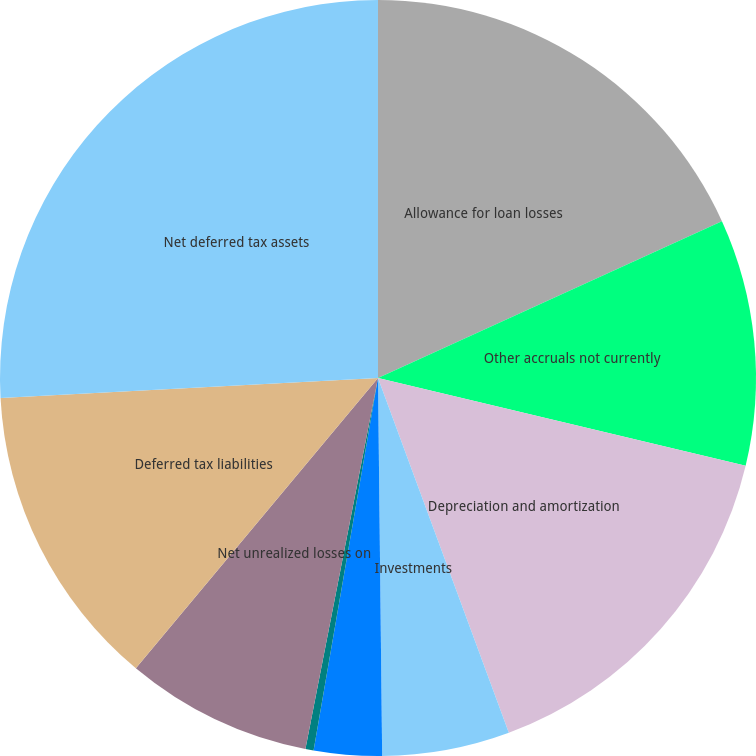Convert chart. <chart><loc_0><loc_0><loc_500><loc_500><pie_chart><fcel>Allowance for loan losses<fcel>Other accruals not currently<fcel>Depreciation and amortization<fcel>Investments<fcel>Losses from pass-through<fcel>Other deferred tax liabilities<fcel>Net unrealized losses on<fcel>Deferred tax liabilities<fcel>Net deferred tax assets<nl><fcel>18.19%<fcel>10.54%<fcel>15.64%<fcel>5.45%<fcel>2.9%<fcel>0.35%<fcel>7.99%<fcel>13.09%<fcel>25.84%<nl></chart> 